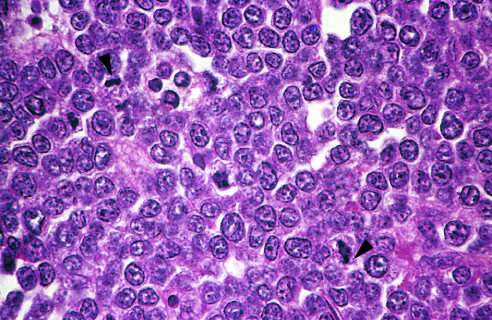re the tumor cells and their nuclei fairly uniform, giving a monotonous appearance?
Answer the question using a single word or phrase. Yes 